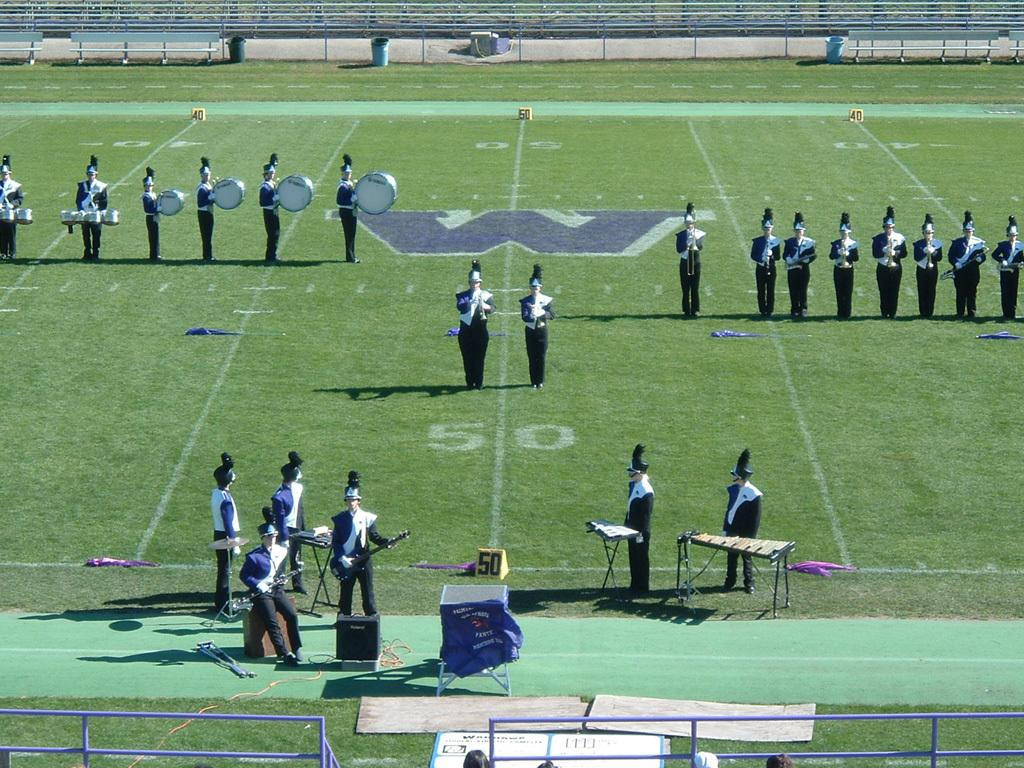<image>
Provide a brief description of the given image. A marching band lines up next to a giant W on the 50 yard line of a football field. 